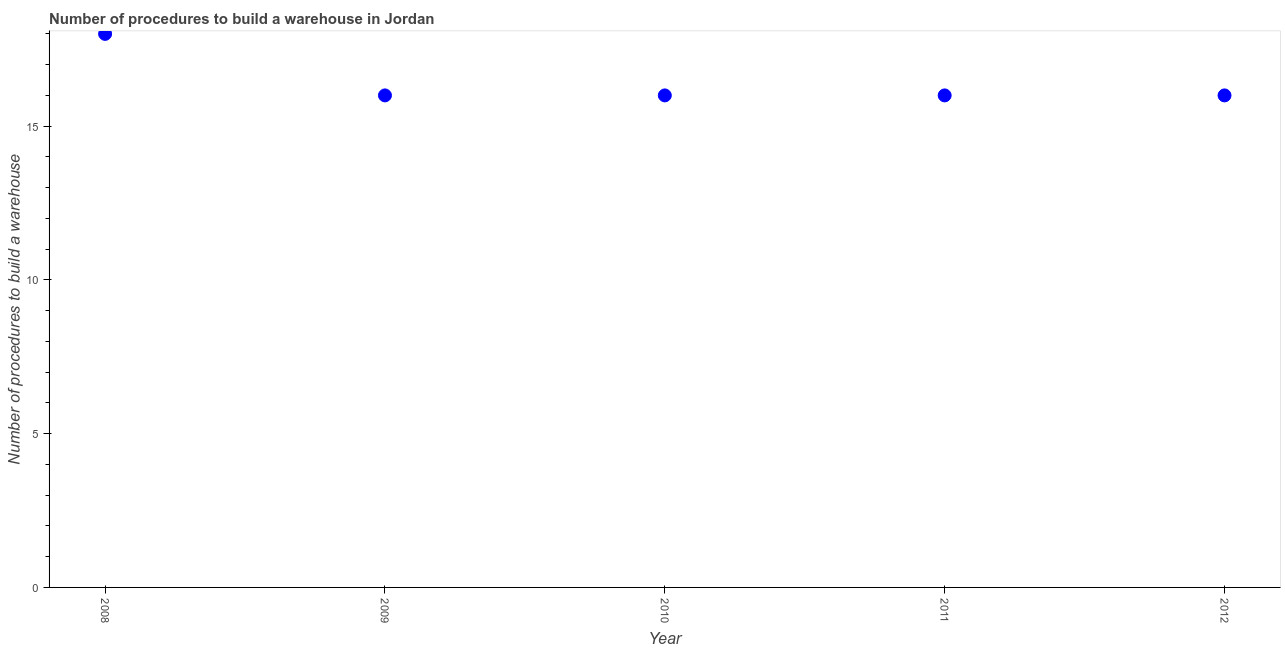What is the number of procedures to build a warehouse in 2008?
Provide a short and direct response. 18. Across all years, what is the maximum number of procedures to build a warehouse?
Provide a succinct answer. 18. Across all years, what is the minimum number of procedures to build a warehouse?
Offer a terse response. 16. In which year was the number of procedures to build a warehouse maximum?
Make the answer very short. 2008. In which year was the number of procedures to build a warehouse minimum?
Ensure brevity in your answer.  2009. What is the sum of the number of procedures to build a warehouse?
Provide a short and direct response. 82. What is the difference between the number of procedures to build a warehouse in 2008 and 2010?
Make the answer very short. 2. Do a majority of the years between 2011 and 2010 (inclusive) have number of procedures to build a warehouse greater than 17 ?
Provide a short and direct response. No. What is the difference between the highest and the second highest number of procedures to build a warehouse?
Provide a short and direct response. 2. What is the difference between the highest and the lowest number of procedures to build a warehouse?
Offer a very short reply. 2. Does the graph contain any zero values?
Ensure brevity in your answer.  No. What is the title of the graph?
Offer a very short reply. Number of procedures to build a warehouse in Jordan. What is the label or title of the Y-axis?
Your answer should be very brief. Number of procedures to build a warehouse. What is the Number of procedures to build a warehouse in 2008?
Make the answer very short. 18. What is the Number of procedures to build a warehouse in 2009?
Offer a very short reply. 16. What is the Number of procedures to build a warehouse in 2010?
Offer a terse response. 16. What is the Number of procedures to build a warehouse in 2011?
Offer a very short reply. 16. What is the difference between the Number of procedures to build a warehouse in 2008 and 2009?
Your answer should be very brief. 2. What is the difference between the Number of procedures to build a warehouse in 2008 and 2011?
Give a very brief answer. 2. What is the difference between the Number of procedures to build a warehouse in 2009 and 2010?
Your response must be concise. 0. What is the difference between the Number of procedures to build a warehouse in 2009 and 2011?
Provide a short and direct response. 0. What is the difference between the Number of procedures to build a warehouse in 2010 and 2012?
Your answer should be very brief. 0. What is the difference between the Number of procedures to build a warehouse in 2011 and 2012?
Your response must be concise. 0. What is the ratio of the Number of procedures to build a warehouse in 2008 to that in 2009?
Keep it short and to the point. 1.12. What is the ratio of the Number of procedures to build a warehouse in 2008 to that in 2011?
Your answer should be very brief. 1.12. What is the ratio of the Number of procedures to build a warehouse in 2008 to that in 2012?
Ensure brevity in your answer.  1.12. What is the ratio of the Number of procedures to build a warehouse in 2009 to that in 2010?
Keep it short and to the point. 1. What is the ratio of the Number of procedures to build a warehouse in 2009 to that in 2011?
Keep it short and to the point. 1. What is the ratio of the Number of procedures to build a warehouse in 2009 to that in 2012?
Your answer should be very brief. 1. What is the ratio of the Number of procedures to build a warehouse in 2010 to that in 2011?
Offer a terse response. 1. What is the ratio of the Number of procedures to build a warehouse in 2011 to that in 2012?
Your answer should be very brief. 1. 